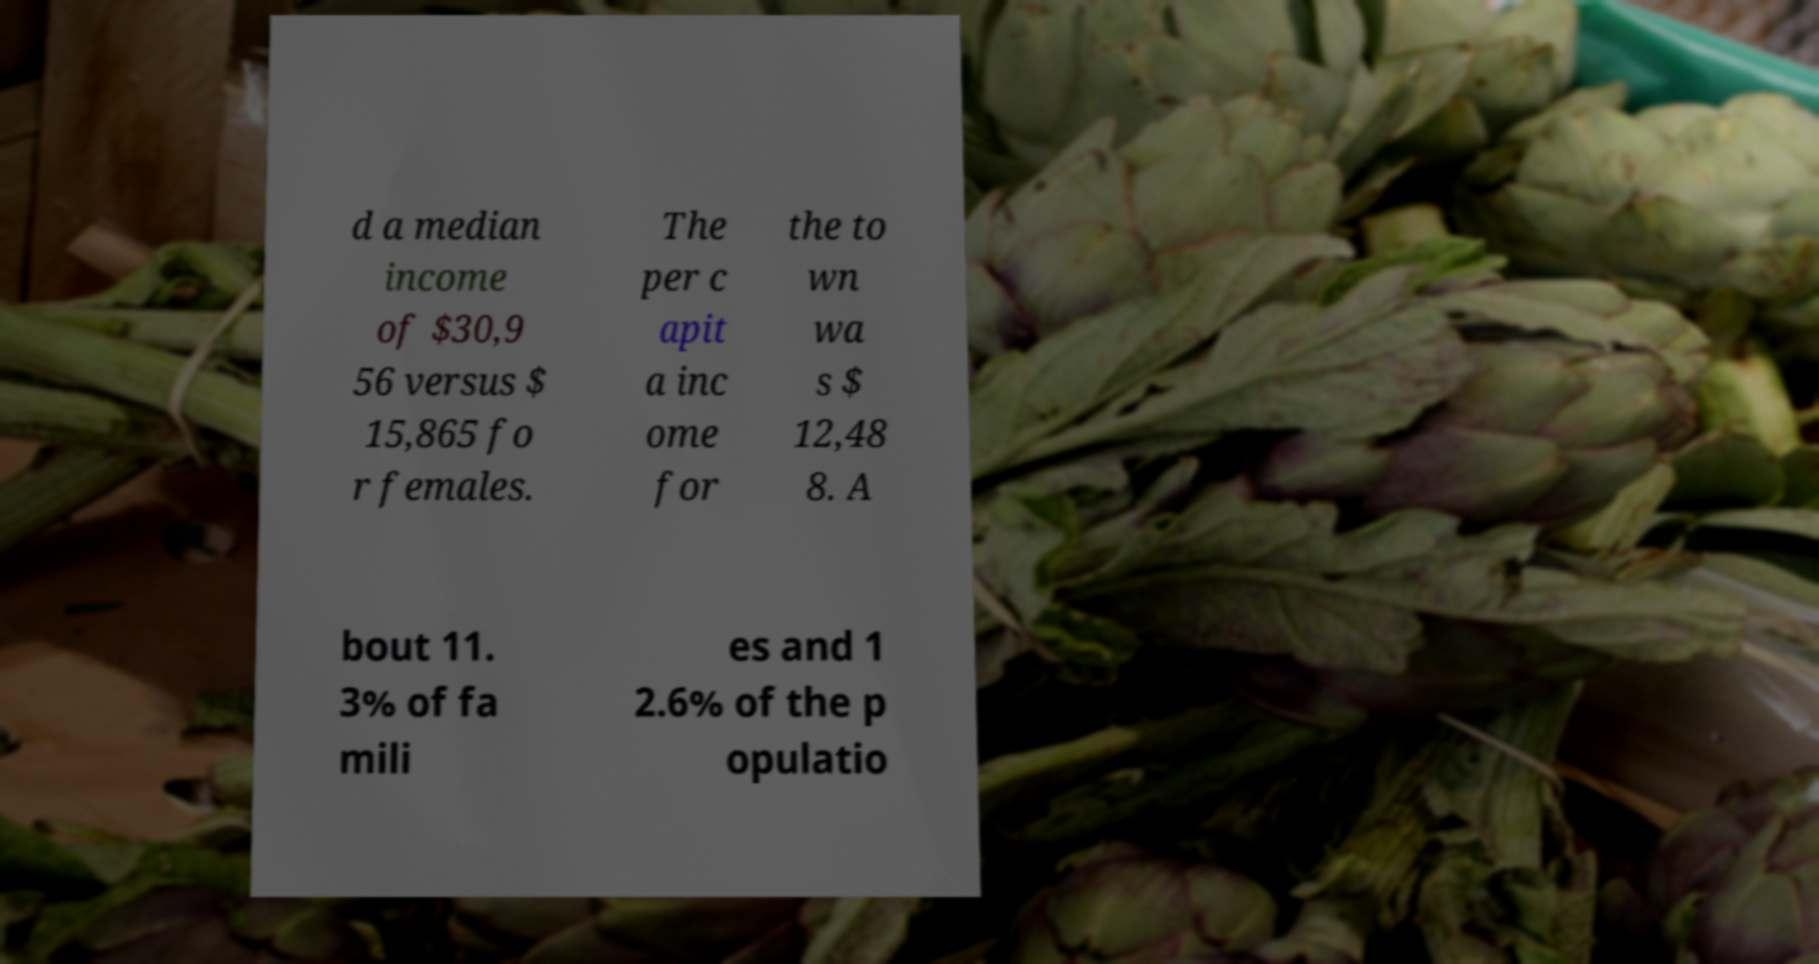Could you extract and type out the text from this image? d a median income of $30,9 56 versus $ 15,865 fo r females. The per c apit a inc ome for the to wn wa s $ 12,48 8. A bout 11. 3% of fa mili es and 1 2.6% of the p opulatio 